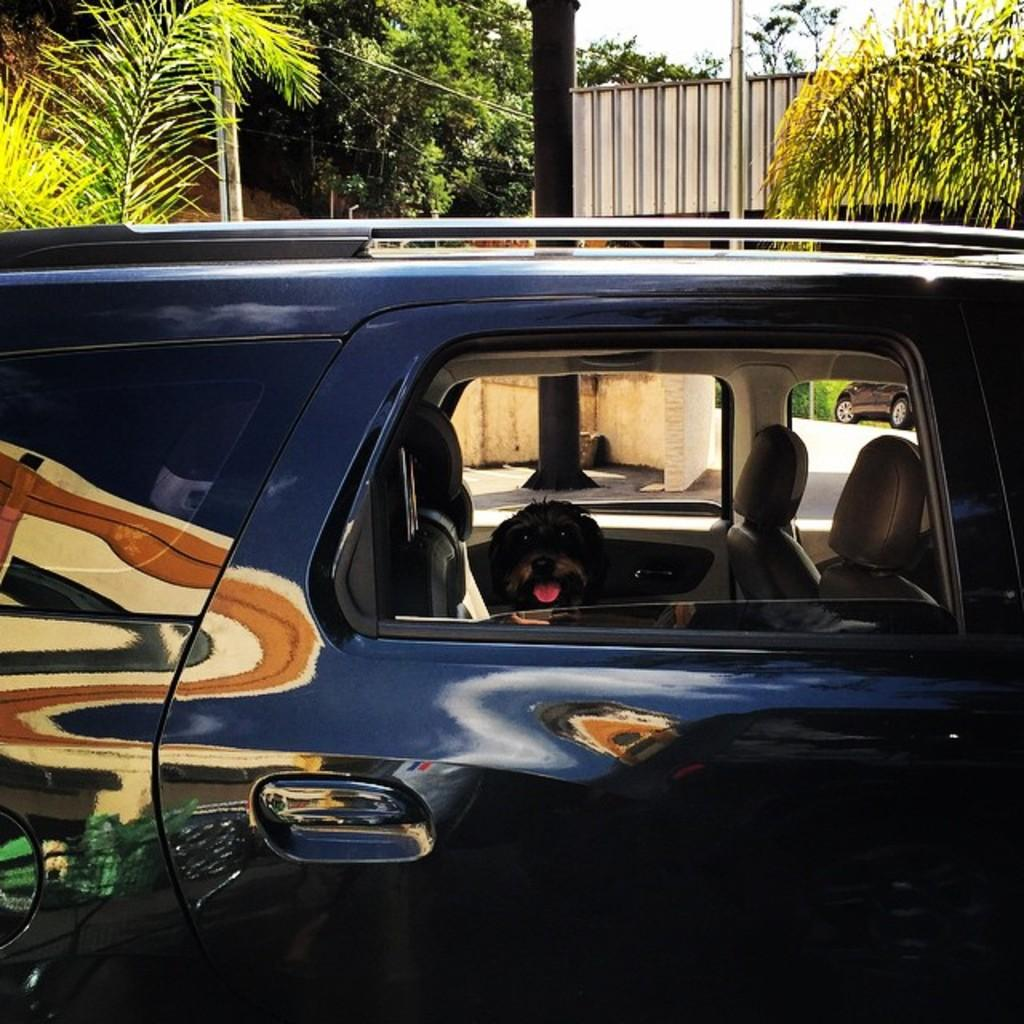What color is the car in the image? The car in the image is blue. What is inside the blue car? There is a dog inside the blue car. What can be seen in the background of the image? There are trees, a pillar, and a wall in the background of the image. How many girls are holding a whip in the image? There are no girls or whips present in the image. 